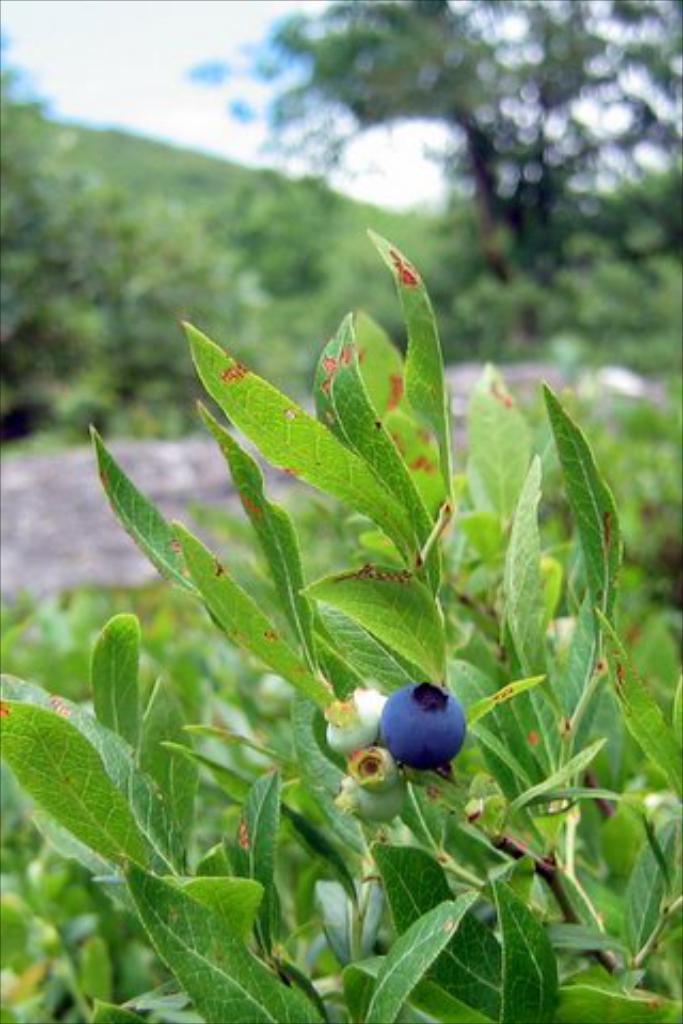Describe this image in one or two sentences. In this image, we can see some plants. Among them, we can see a plant with some berries. We can also see the blurred background. 